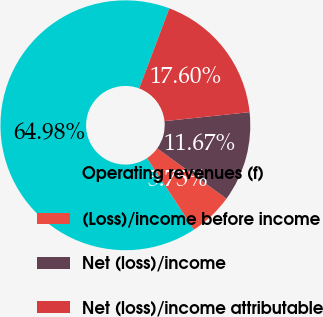Convert chart to OTSL. <chart><loc_0><loc_0><loc_500><loc_500><pie_chart><fcel>Operating revenues (f)<fcel>(Loss)/income before income<fcel>Net (loss)/income<fcel>Net (loss)/income attributable<nl><fcel>64.98%<fcel>5.75%<fcel>11.67%<fcel>17.6%<nl></chart> 